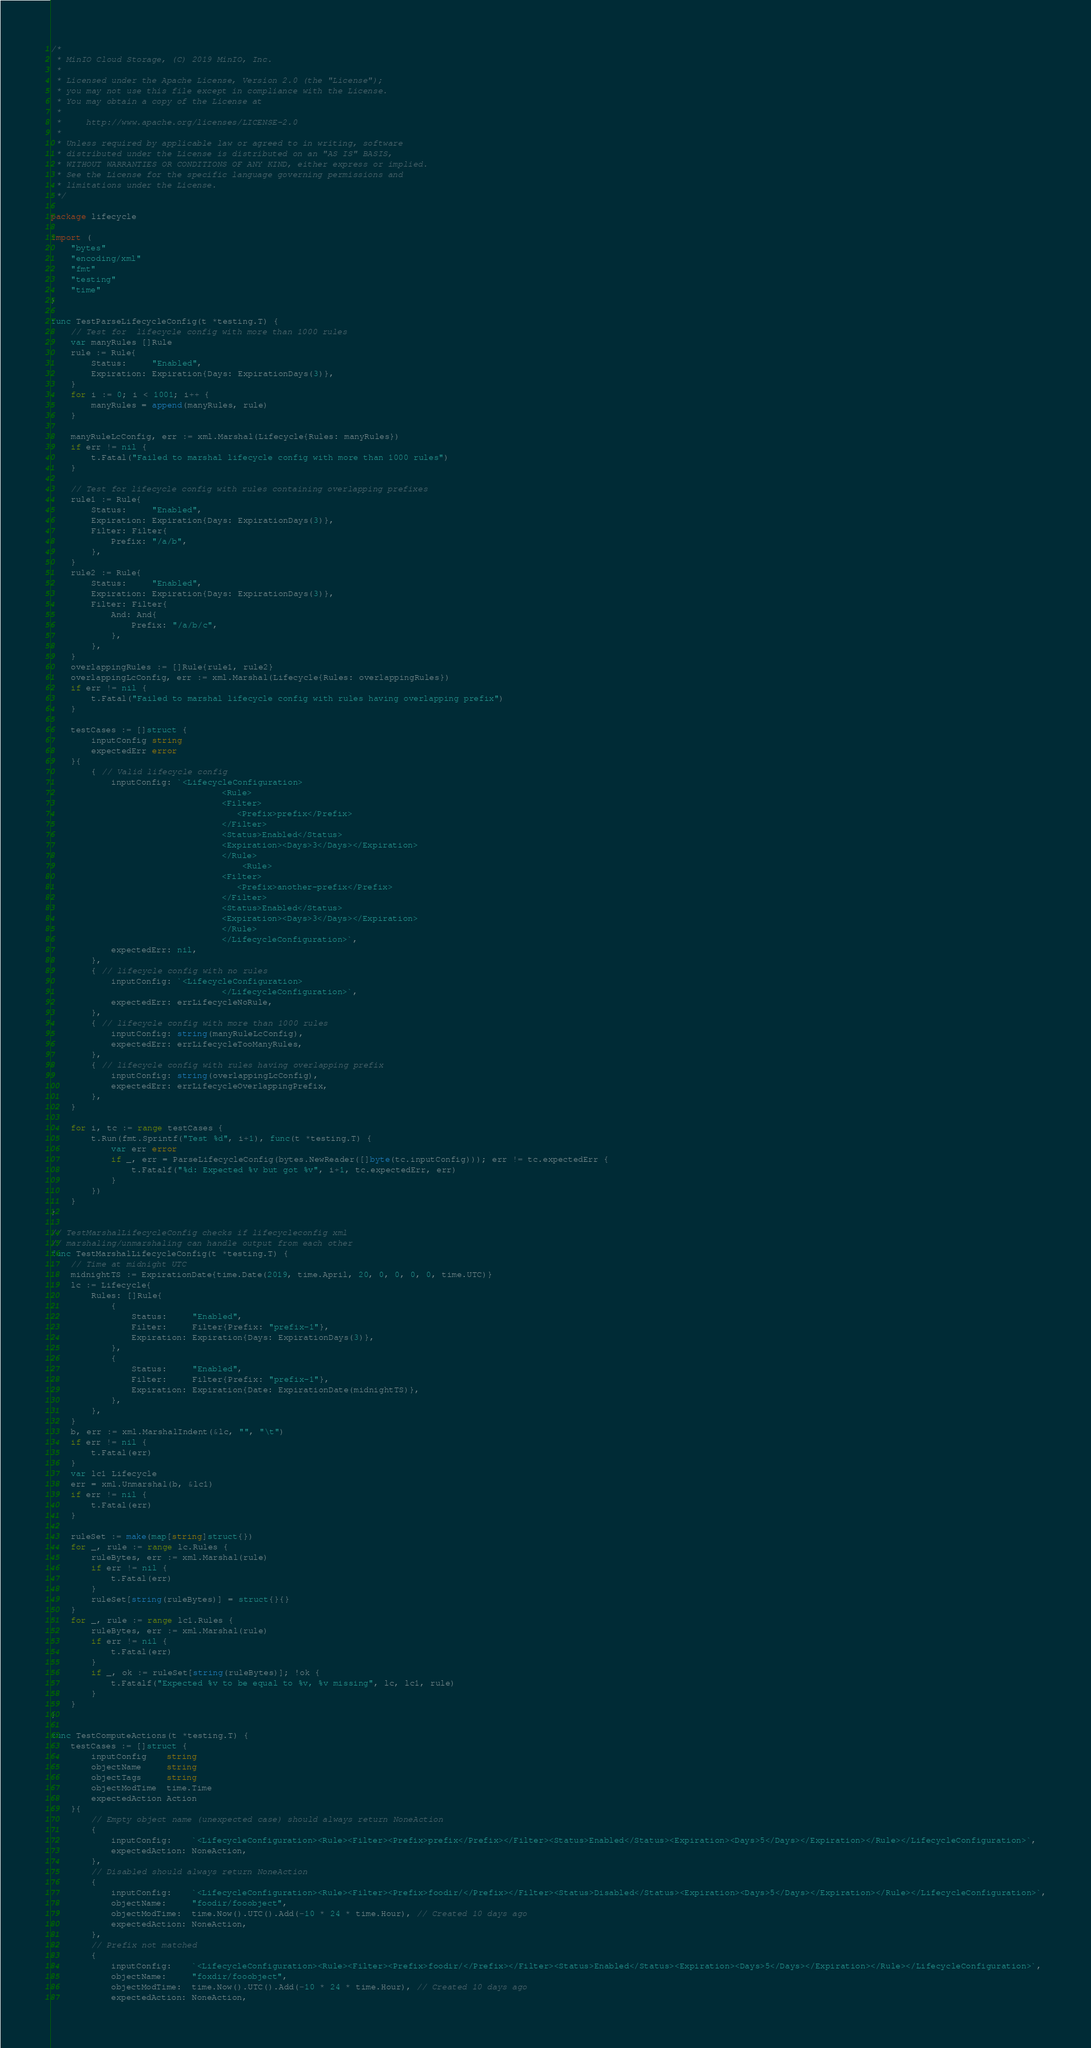Convert code to text. <code><loc_0><loc_0><loc_500><loc_500><_Go_>/*
 * MinIO Cloud Storage, (C) 2019 MinIO, Inc.
 *
 * Licensed under the Apache License, Version 2.0 (the "License");
 * you may not use this file except in compliance with the License.
 * You may obtain a copy of the License at
 *
 *     http://www.apache.org/licenses/LICENSE-2.0
 *
 * Unless required by applicable law or agreed to in writing, software
 * distributed under the License is distributed on an "AS IS" BASIS,
 * WITHOUT WARRANTIES OR CONDITIONS OF ANY KIND, either express or implied.
 * See the License for the specific language governing permissions and
 * limitations under the License.
 */

package lifecycle

import (
	"bytes"
	"encoding/xml"
	"fmt"
	"testing"
	"time"
)

func TestParseLifecycleConfig(t *testing.T) {
	// Test for  lifecycle config with more than 1000 rules
	var manyRules []Rule
	rule := Rule{
		Status:     "Enabled",
		Expiration: Expiration{Days: ExpirationDays(3)},
	}
	for i := 0; i < 1001; i++ {
		manyRules = append(manyRules, rule)
	}

	manyRuleLcConfig, err := xml.Marshal(Lifecycle{Rules: manyRules})
	if err != nil {
		t.Fatal("Failed to marshal lifecycle config with more than 1000 rules")
	}

	// Test for lifecycle config with rules containing overlapping prefixes
	rule1 := Rule{
		Status:     "Enabled",
		Expiration: Expiration{Days: ExpirationDays(3)},
		Filter: Filter{
			Prefix: "/a/b",
		},
	}
	rule2 := Rule{
		Status:     "Enabled",
		Expiration: Expiration{Days: ExpirationDays(3)},
		Filter: Filter{
			And: And{
				Prefix: "/a/b/c",
			},
		},
	}
	overlappingRules := []Rule{rule1, rule2}
	overlappingLcConfig, err := xml.Marshal(Lifecycle{Rules: overlappingRules})
	if err != nil {
		t.Fatal("Failed to marshal lifecycle config with rules having overlapping prefix")
	}

	testCases := []struct {
		inputConfig string
		expectedErr error
	}{
		{ // Valid lifecycle config
			inputConfig: `<LifecycleConfiguration>
		                          <Rule>
		                          <Filter>
		                             <Prefix>prefix</Prefix>
		                          </Filter>
		                          <Status>Enabled</Status>
		                          <Expiration><Days>3</Days></Expiration>
		                          </Rule>
		                              <Rule>
		                          <Filter>
		                             <Prefix>another-prefix</Prefix>
		                          </Filter>
		                          <Status>Enabled</Status>
		                          <Expiration><Days>3</Days></Expiration>
		                          </Rule>
		                          </LifecycleConfiguration>`,
			expectedErr: nil,
		},
		{ // lifecycle config with no rules
			inputConfig: `<LifecycleConfiguration>
		                          </LifecycleConfiguration>`,
			expectedErr: errLifecycleNoRule,
		},
		{ // lifecycle config with more than 1000 rules
			inputConfig: string(manyRuleLcConfig),
			expectedErr: errLifecycleTooManyRules,
		},
		{ // lifecycle config with rules having overlapping prefix
			inputConfig: string(overlappingLcConfig),
			expectedErr: errLifecycleOverlappingPrefix,
		},
	}

	for i, tc := range testCases {
		t.Run(fmt.Sprintf("Test %d", i+1), func(t *testing.T) {
			var err error
			if _, err = ParseLifecycleConfig(bytes.NewReader([]byte(tc.inputConfig))); err != tc.expectedErr {
				t.Fatalf("%d: Expected %v but got %v", i+1, tc.expectedErr, err)
			}
		})
	}
}

// TestMarshalLifecycleConfig checks if lifecycleconfig xml
// marshaling/unmarshaling can handle output from each other
func TestMarshalLifecycleConfig(t *testing.T) {
	// Time at midnight UTC
	midnightTS := ExpirationDate{time.Date(2019, time.April, 20, 0, 0, 0, 0, time.UTC)}
	lc := Lifecycle{
		Rules: []Rule{
			{
				Status:     "Enabled",
				Filter:     Filter{Prefix: "prefix-1"},
				Expiration: Expiration{Days: ExpirationDays(3)},
			},
			{
				Status:     "Enabled",
				Filter:     Filter{Prefix: "prefix-1"},
				Expiration: Expiration{Date: ExpirationDate(midnightTS)},
			},
		},
	}
	b, err := xml.MarshalIndent(&lc, "", "\t")
	if err != nil {
		t.Fatal(err)
	}
	var lc1 Lifecycle
	err = xml.Unmarshal(b, &lc1)
	if err != nil {
		t.Fatal(err)
	}

	ruleSet := make(map[string]struct{})
	for _, rule := range lc.Rules {
		ruleBytes, err := xml.Marshal(rule)
		if err != nil {
			t.Fatal(err)
		}
		ruleSet[string(ruleBytes)] = struct{}{}
	}
	for _, rule := range lc1.Rules {
		ruleBytes, err := xml.Marshal(rule)
		if err != nil {
			t.Fatal(err)
		}
		if _, ok := ruleSet[string(ruleBytes)]; !ok {
			t.Fatalf("Expected %v to be equal to %v, %v missing", lc, lc1, rule)
		}
	}
}

func TestComputeActions(t *testing.T) {
	testCases := []struct {
		inputConfig    string
		objectName     string
		objectTags     string
		objectModTime  time.Time
		expectedAction Action
	}{
		// Empty object name (unexpected case) should always return NoneAction
		{
			inputConfig:    `<LifecycleConfiguration><Rule><Filter><Prefix>prefix</Prefix></Filter><Status>Enabled</Status><Expiration><Days>5</Days></Expiration></Rule></LifecycleConfiguration>`,
			expectedAction: NoneAction,
		},
		// Disabled should always return NoneAction
		{
			inputConfig:    `<LifecycleConfiguration><Rule><Filter><Prefix>foodir/</Prefix></Filter><Status>Disabled</Status><Expiration><Days>5</Days></Expiration></Rule></LifecycleConfiguration>`,
			objectName:     "foodir/fooobject",
			objectModTime:  time.Now().UTC().Add(-10 * 24 * time.Hour), // Created 10 days ago
			expectedAction: NoneAction,
		},
		// Prefix not matched
		{
			inputConfig:    `<LifecycleConfiguration><Rule><Filter><Prefix>foodir/</Prefix></Filter><Status>Enabled</Status><Expiration><Days>5</Days></Expiration></Rule></LifecycleConfiguration>`,
			objectName:     "foxdir/fooobject",
			objectModTime:  time.Now().UTC().Add(-10 * 24 * time.Hour), // Created 10 days ago
			expectedAction: NoneAction,</code> 